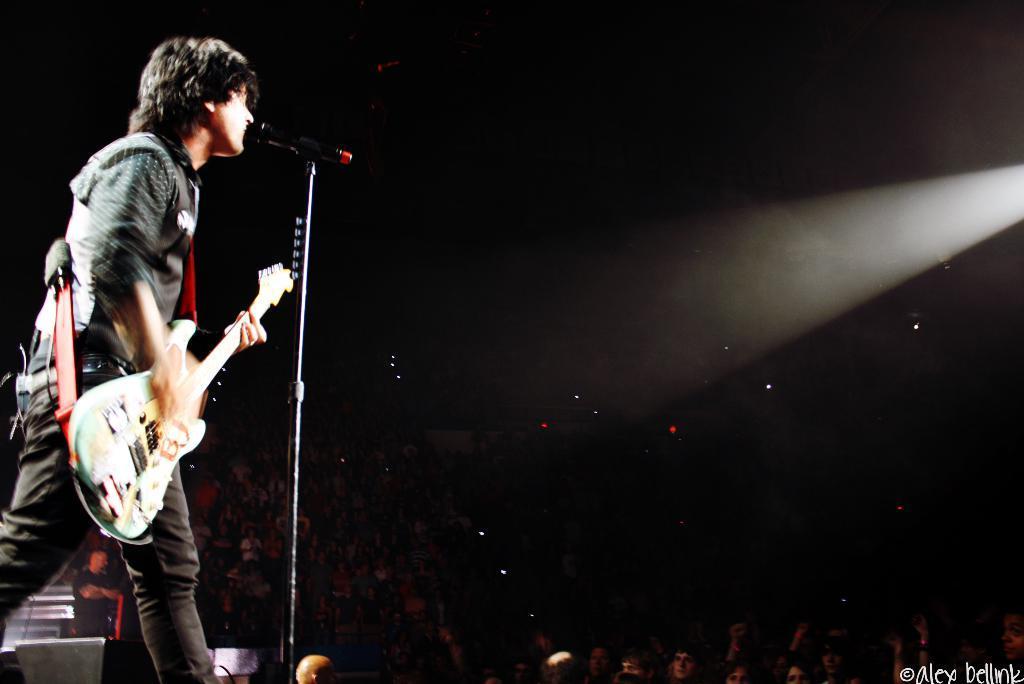Can you describe this image briefly? On the left side there is a man who is standing with a guitar and he is singing near to a mic. On the bottom we can see a crowd. On the right there is a light 